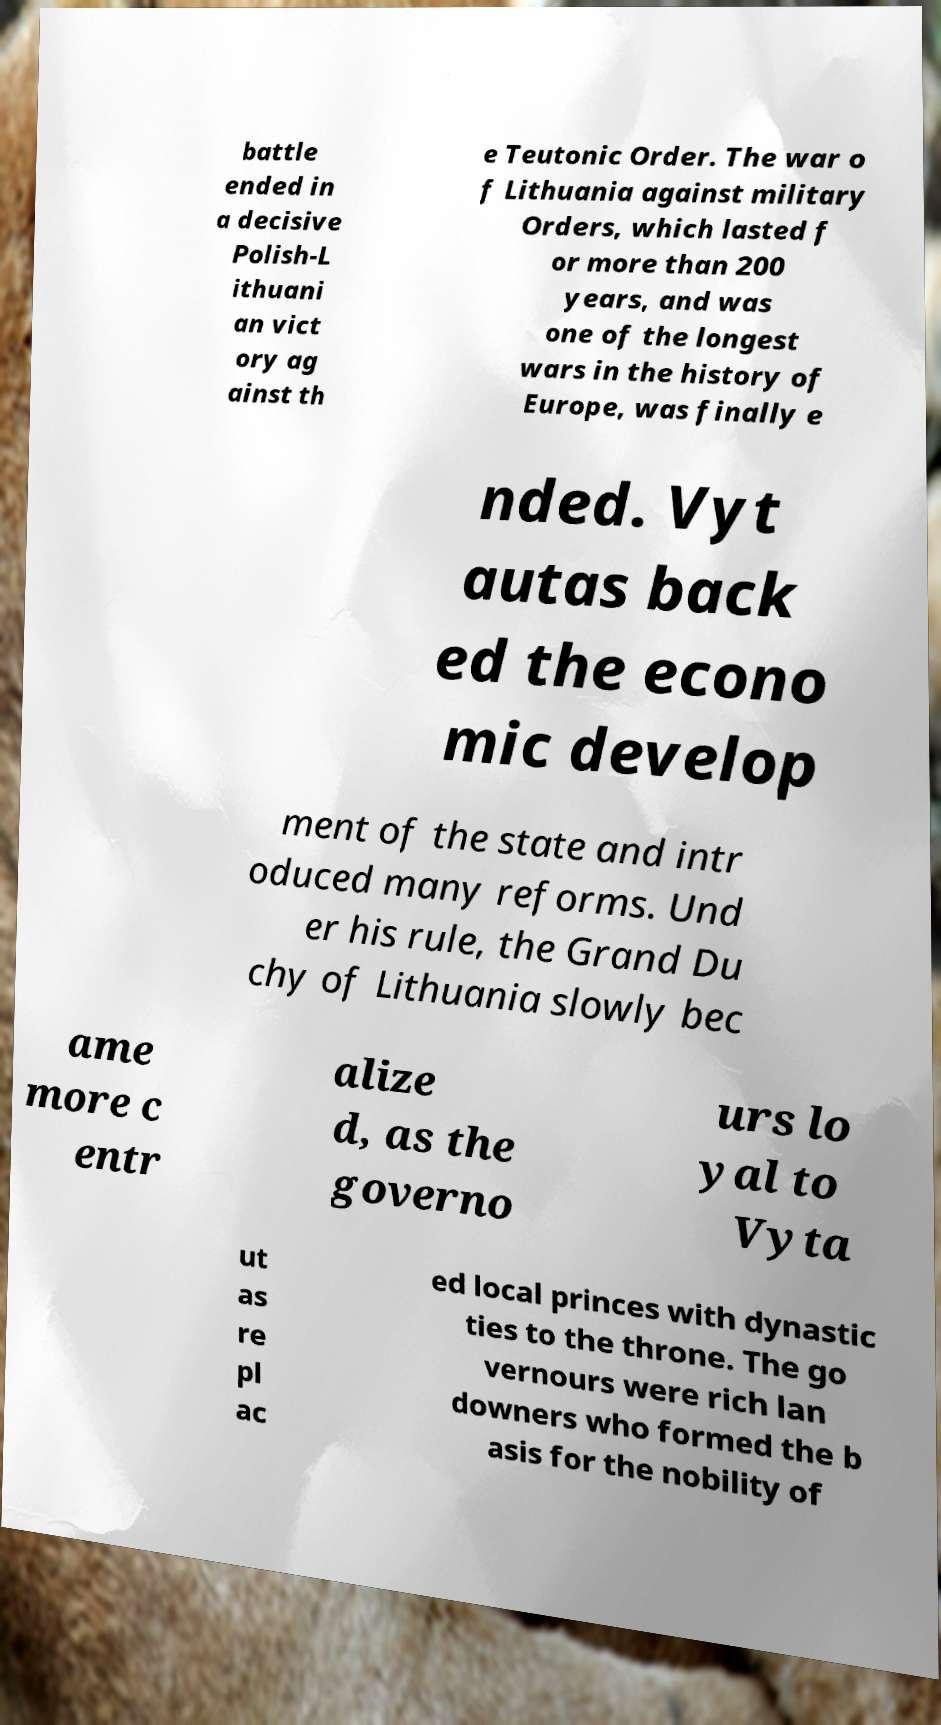What messages or text are displayed in this image? I need them in a readable, typed format. battle ended in a decisive Polish-L ithuani an vict ory ag ainst th e Teutonic Order. The war o f Lithuania against military Orders, which lasted f or more than 200 years, and was one of the longest wars in the history of Europe, was finally e nded. Vyt autas back ed the econo mic develop ment of the state and intr oduced many reforms. Und er his rule, the Grand Du chy of Lithuania slowly bec ame more c entr alize d, as the governo urs lo yal to Vyta ut as re pl ac ed local princes with dynastic ties to the throne. The go vernours were rich lan downers who formed the b asis for the nobility of 